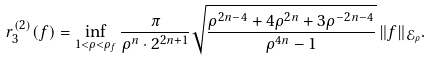Convert formula to latex. <formula><loc_0><loc_0><loc_500><loc_500>r ^ { ( 2 ) } _ { 3 } ( f ) = \inf _ { 1 < \rho < \rho _ { f } } \frac { \pi } { \rho ^ { n } \cdot 2 ^ { 2 n + 1 } } \sqrt { \frac { \rho ^ { 2 n - 4 } + 4 \rho ^ { 2 n } + 3 \rho ^ { - 2 n - 4 } } { \rho ^ { 4 n } - 1 } } \, \| f \| _ { \mathcal { E } _ { \rho } } .</formula> 